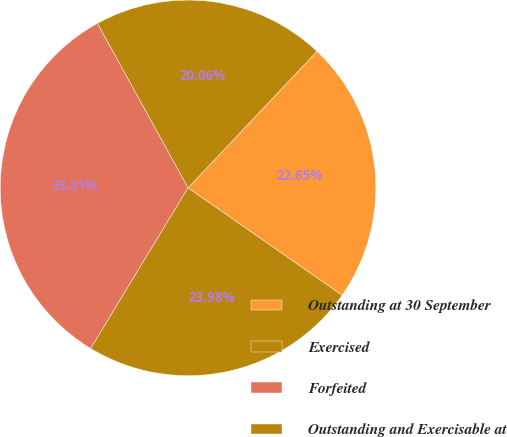Convert chart to OTSL. <chart><loc_0><loc_0><loc_500><loc_500><pie_chart><fcel>Outstanding at 30 September<fcel>Exercised<fcel>Forfeited<fcel>Outstanding and Exercisable at<nl><fcel>22.65%<fcel>20.06%<fcel>33.31%<fcel>23.98%<nl></chart> 